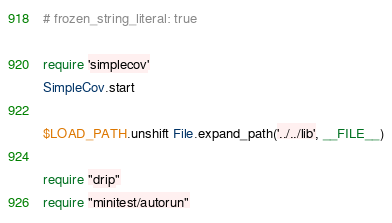Convert code to text. <code><loc_0><loc_0><loc_500><loc_500><_Ruby_># frozen_string_literal: true

require 'simplecov'
SimpleCov.start

$LOAD_PATH.unshift File.expand_path('../../lib', __FILE__)

require "drip"
require "minitest/autorun"</code> 